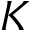Convert formula to latex. <formula><loc_0><loc_0><loc_500><loc_500>K</formula> 